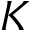Convert formula to latex. <formula><loc_0><loc_0><loc_500><loc_500>K</formula> 